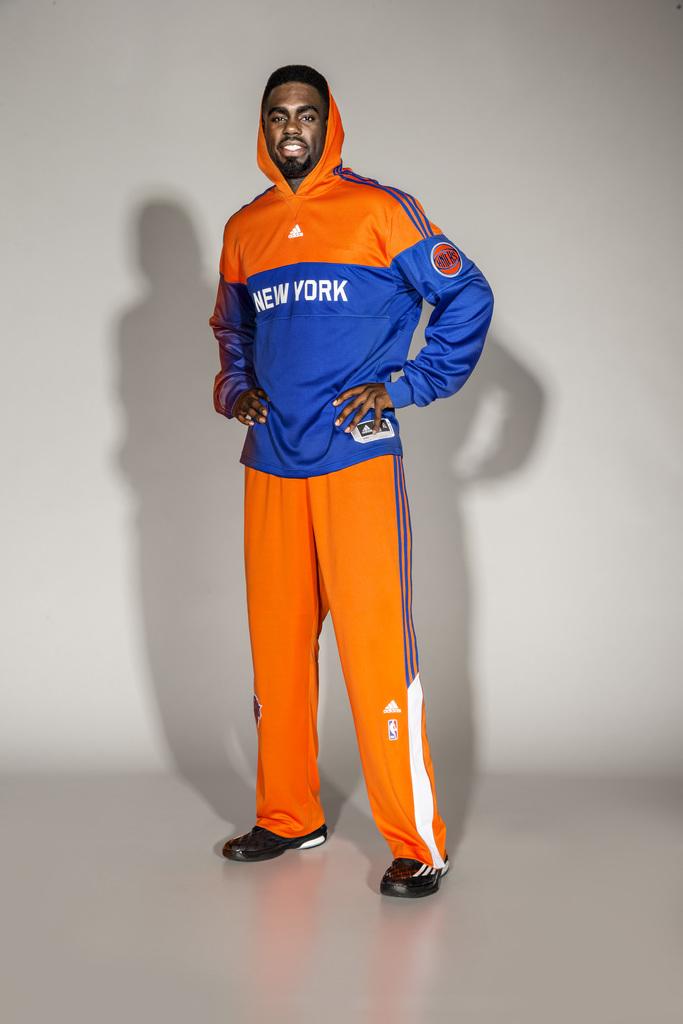Is the name on the hoodie a sports team?
Ensure brevity in your answer.  No. 